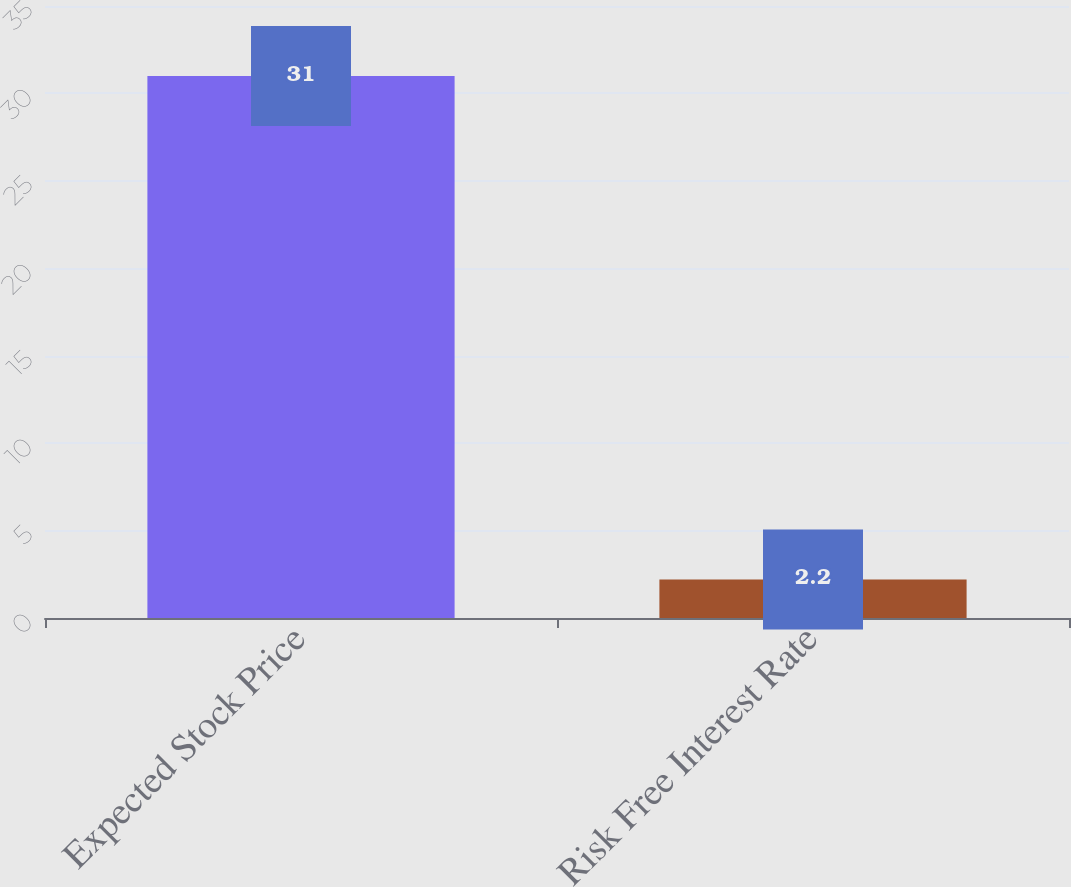Convert chart to OTSL. <chart><loc_0><loc_0><loc_500><loc_500><bar_chart><fcel>Expected Stock Price<fcel>Risk Free Interest Rate<nl><fcel>31<fcel>2.2<nl></chart> 